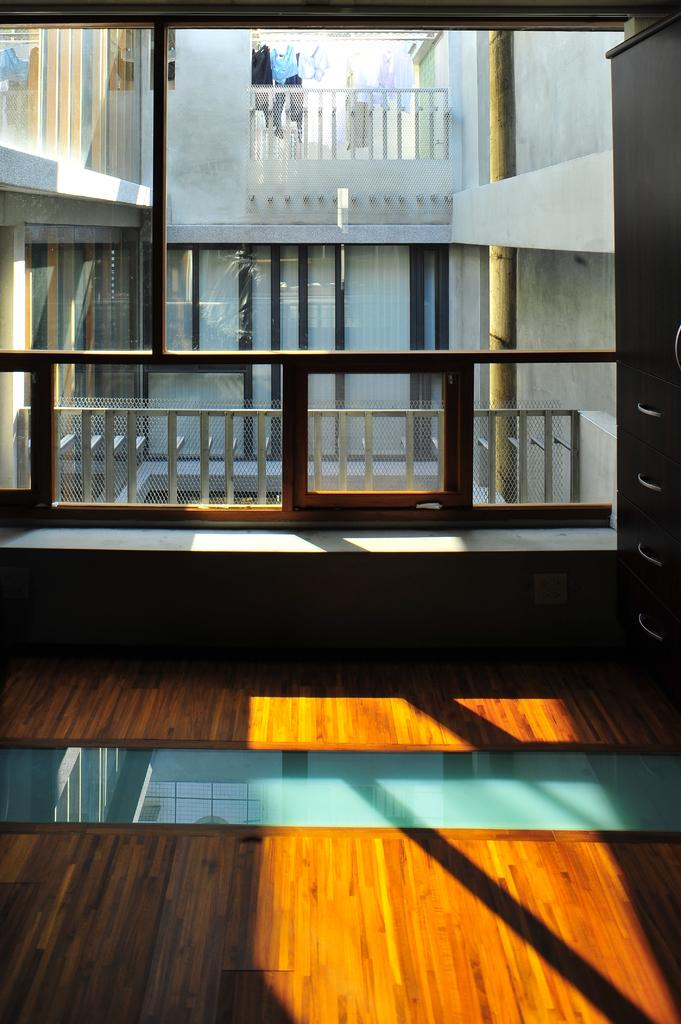What type of material can be seen in the windows in the image? There are glass windows in the image. What type of barrier is present in the image? There is fencing in the image. What vertical structure can be seen in the image? There is a pole in the image. What feature allows access to the building in the image? There is a door in the image. What type of structure is depicted in the image? There is a building in the image. What type of veil is draped over the building in the image? There is no veil present in the image; it only features a building, windows, fencing, a pole, and a door. What effect does the pole have on the surrounding environment in the image? The pole does not have any visible effect on the surrounding environment in the image. 